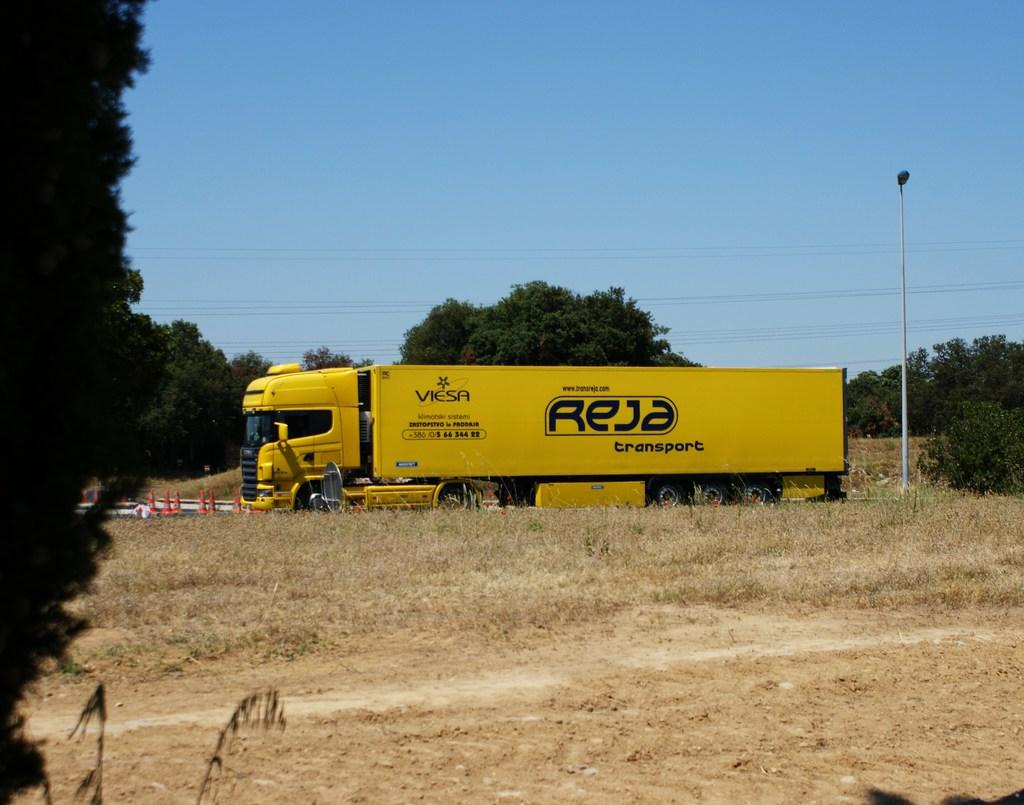What type of vehicle is in the image? There is a yellow vehicle in the image. What can be seen in the background of the image? There are trees and a light pole in the background of the image. What color are the trees in the image? The trees are green. What color is the sky in the image? The sky is blue. What type of treatment is the bear receiving from the crook in the image? There is no bear or crook present in the image; it only features a yellow vehicle, trees, a light pole, and a blue sky. 